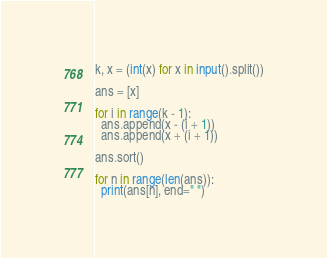Convert code to text. <code><loc_0><loc_0><loc_500><loc_500><_Python_>k, x = (int(x) for x in input().split())

ans = [x]

for i in range(k - 1):
  ans.append(x - (i + 1))
  ans.append(x + (i + 1))

ans.sort()

for n in range(len(ans)):
  print(ans[n], end=" ")

</code> 